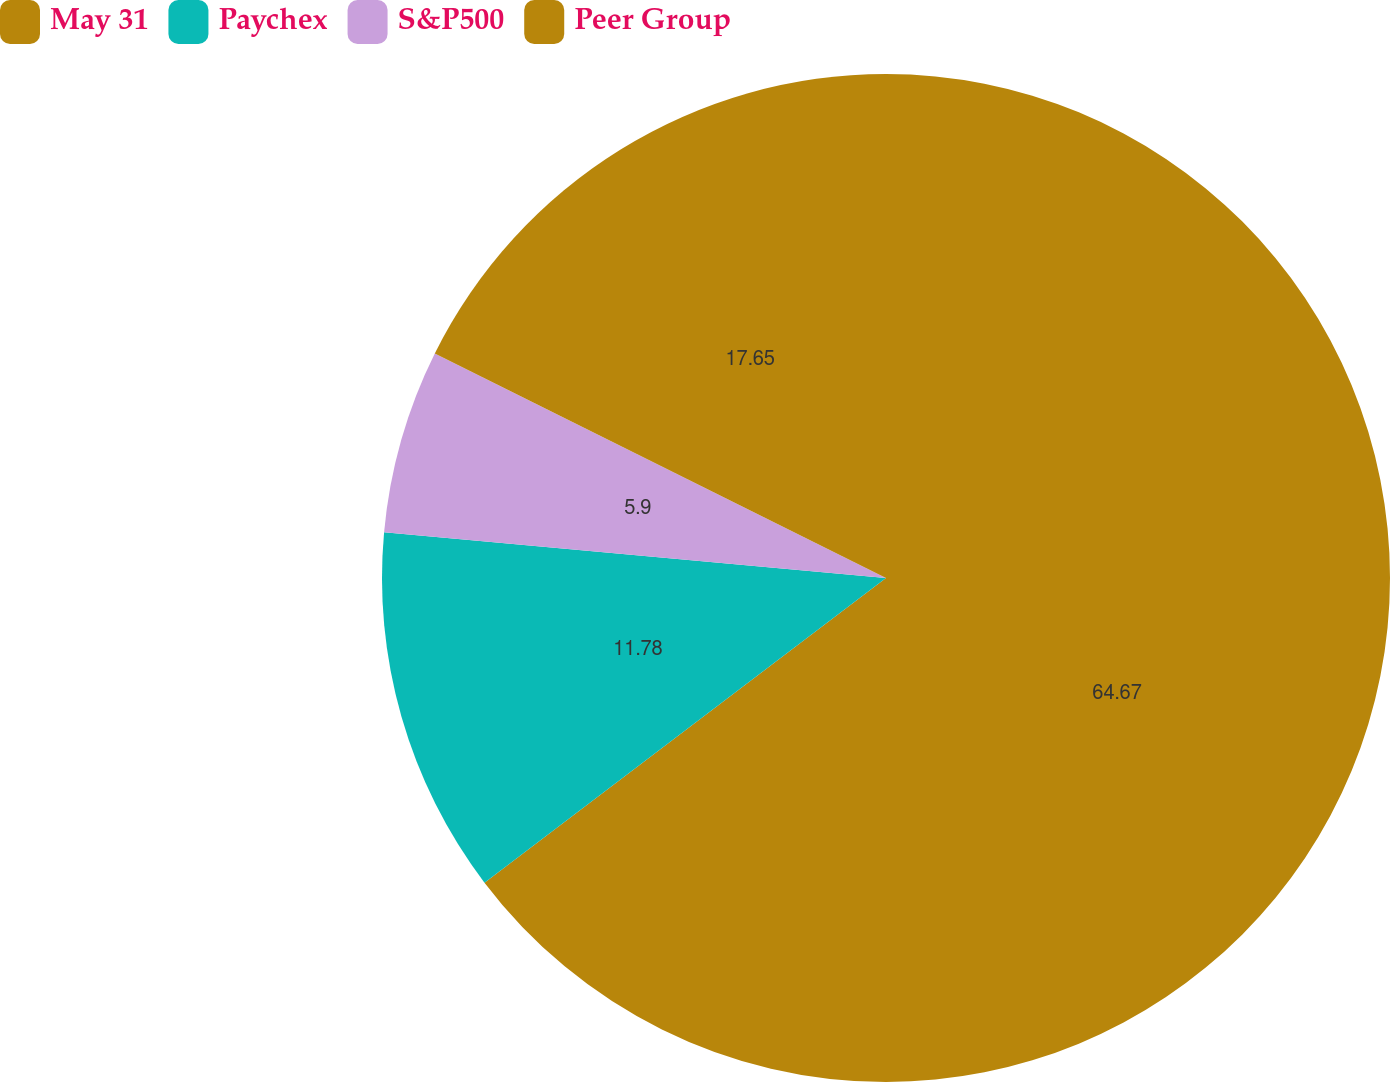<chart> <loc_0><loc_0><loc_500><loc_500><pie_chart><fcel>May 31<fcel>Paychex<fcel>S&P500<fcel>Peer Group<nl><fcel>64.67%<fcel>11.78%<fcel>5.9%<fcel>17.65%<nl></chart> 